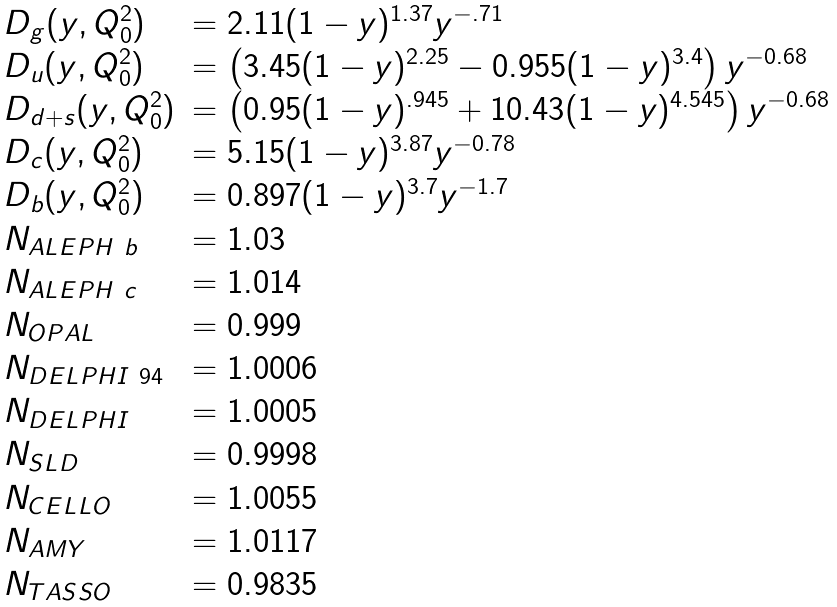<formula> <loc_0><loc_0><loc_500><loc_500>\begin{array} { l l } D _ { g } ( y , Q _ { 0 } ^ { 2 } ) & = 2 . 1 1 ( 1 - y ) ^ { 1 . 3 7 } y ^ { - . 7 1 } \\ D _ { u } ( y , Q _ { 0 } ^ { 2 } ) & = \left ( 3 . 4 5 ( 1 - y ) ^ { 2 . 2 5 } - 0 . 9 5 5 ( 1 - y ) ^ { 3 . 4 } \right ) y ^ { - 0 . 6 8 } \\ D _ { d + s } ( y , Q _ { 0 } ^ { 2 } ) & = \left ( 0 . 9 5 ( 1 - y ) ^ { . 9 4 5 } + 1 0 . 4 3 ( 1 - y ) ^ { 4 . 5 4 5 } \right ) y ^ { - 0 . 6 8 } \\ D _ { c } ( y , Q _ { 0 } ^ { 2 } ) & = 5 . 1 5 ( 1 - y ) ^ { 3 . 8 7 } y ^ { - 0 . 7 8 } \\ D _ { b } ( y , Q _ { 0 } ^ { 2 } ) & = 0 . 8 9 7 ( 1 - y ) ^ { 3 . 7 } y ^ { - 1 . 7 } \\ N _ { A L E P H \ b } & = 1 . 0 3 \\ N _ { A L E P H \ c } & = 1 . 0 1 4 \\ N _ { O P A L } & = 0 . 9 9 9 \\ N _ { D E L P H I \ 9 4 } & = 1 . 0 0 0 6 \\ N _ { D E L P H I } & = 1 . 0 0 0 5 \\ N _ { S L D } & = 0 . 9 9 9 8 \\ N _ { C E L L O } & = 1 . 0 0 5 5 \\ N _ { A M Y } & = 1 . 0 1 1 7 \\ N _ { T A S S O } & = 0 . 9 8 3 5 \\ \end{array}</formula> 